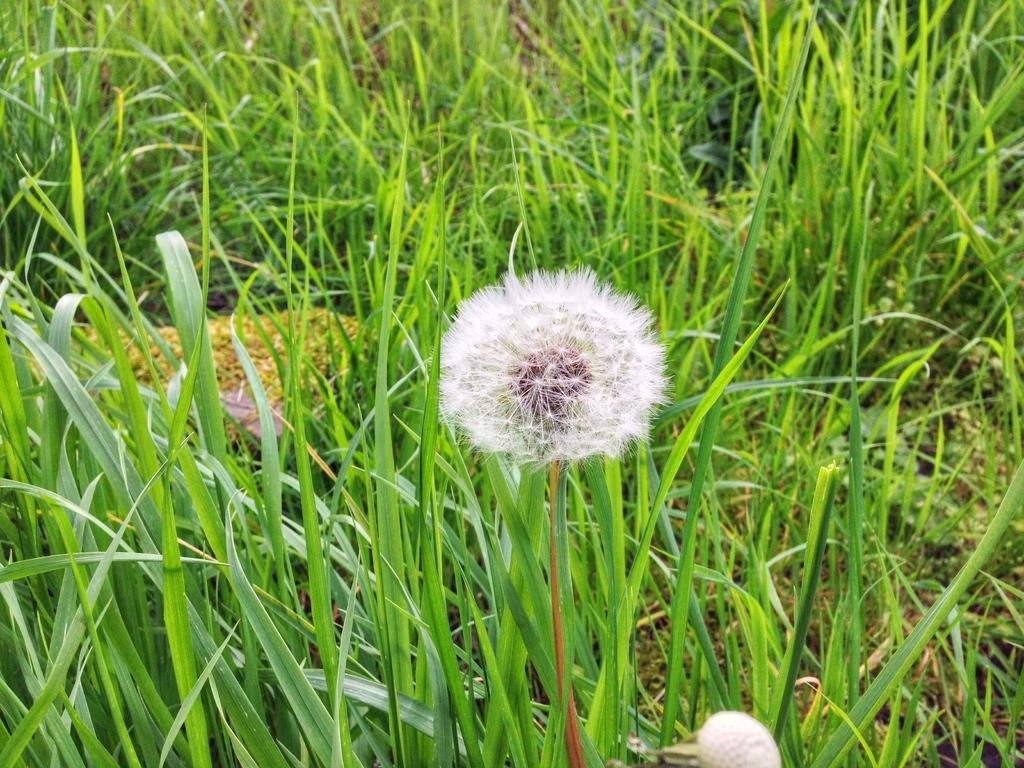What type of plant is in the image? There is a dandelion in the image. What type of vegetation is visible in the image? There is grass in the image. What other objects can be seen in the image besides the dandelion and grass? There are other objects in the image. What type of copper locket can be seen hanging from the dandelion in the image? There is no copper locket present in the image, and the dandelion is not holding any object. Can you tell me how many rabbits are visible in the image? There are no rabbits present in the image. 